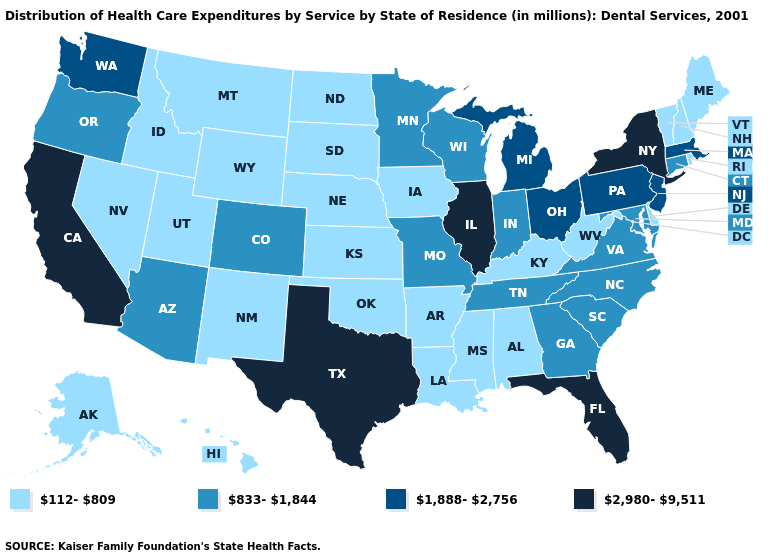Is the legend a continuous bar?
Short answer required. No. Name the states that have a value in the range 2,980-9,511?
Be succinct. California, Florida, Illinois, New York, Texas. What is the value of Missouri?
Be succinct. 833-1,844. Does Ohio have the lowest value in the MidWest?
Quick response, please. No. What is the value of New York?
Concise answer only. 2,980-9,511. Does Virginia have a higher value than New Hampshire?
Quick response, please. Yes. What is the value of Maryland?
Keep it brief. 833-1,844. Name the states that have a value in the range 2,980-9,511?
Keep it brief. California, Florida, Illinois, New York, Texas. Does Kentucky have the lowest value in the South?
Concise answer only. Yes. What is the highest value in states that border Rhode Island?
Keep it brief. 1,888-2,756. Does North Carolina have the highest value in the USA?
Quick response, please. No. Does the map have missing data?
Quick response, please. No. Does the first symbol in the legend represent the smallest category?
Answer briefly. Yes. Is the legend a continuous bar?
Give a very brief answer. No. What is the value of Missouri?
Be succinct. 833-1,844. 